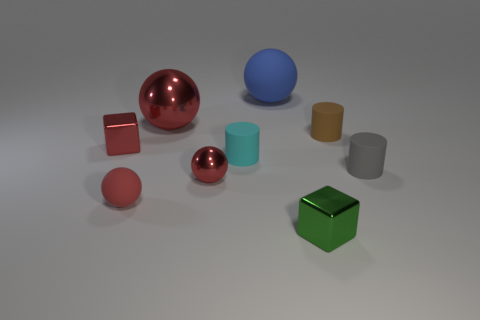Are there any metal objects on the right side of the small metallic block that is to the left of the large sphere to the left of the blue sphere?
Your response must be concise. Yes. The small sphere that is the same material as the big red ball is what color?
Provide a succinct answer. Red. There is a metallic block left of the large blue ball; does it have the same color as the large shiny sphere?
Keep it short and to the point. Yes. What number of cylinders are small cyan shiny things or matte objects?
Offer a terse response. 3. There is a brown object that is behind the red sphere on the left side of the shiny sphere behind the brown cylinder; what is its size?
Make the answer very short. Small. What shape is the cyan thing that is the same size as the green object?
Give a very brief answer. Cylinder. The large shiny object is what shape?
Your response must be concise. Sphere. Is the material of the thing that is to the right of the brown cylinder the same as the big red thing?
Your answer should be compact. No. There is a red ball that is behind the red metallic thing that is in front of the tiny gray cylinder; what is its size?
Your response must be concise. Large. What color is the sphere that is both in front of the tiny brown cylinder and to the right of the big metallic sphere?
Give a very brief answer. Red. 